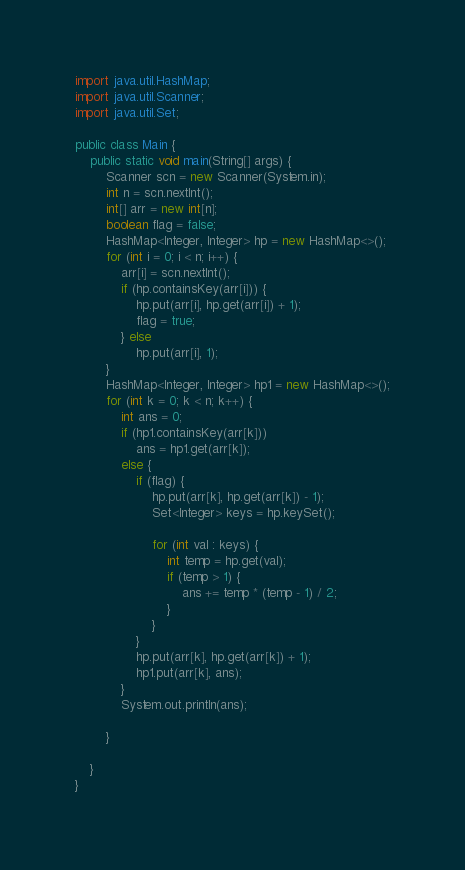<code> <loc_0><loc_0><loc_500><loc_500><_Java_>import java.util.HashMap;
import java.util.Scanner;
import java.util.Set;

public class Main {
	public static void main(String[] args) {
		Scanner scn = new Scanner(System.in);
		int n = scn.nextInt();
		int[] arr = new int[n];
		boolean flag = false;
		HashMap<Integer, Integer> hp = new HashMap<>();
		for (int i = 0; i < n; i++) {
			arr[i] = scn.nextInt();
			if (hp.containsKey(arr[i])) {
				hp.put(arr[i], hp.get(arr[i]) + 1);
				flag = true;
			} else
				hp.put(arr[i], 1);
		}
		HashMap<Integer, Integer> hp1 = new HashMap<>();
		for (int k = 0; k < n; k++) {
			int ans = 0;
			if (hp1.containsKey(arr[k]))
				ans = hp1.get(arr[k]);
			else {
				if (flag) {
					hp.put(arr[k], hp.get(arr[k]) - 1);
					Set<Integer> keys = hp.keySet();

					for (int val : keys) {
						int temp = hp.get(val);
						if (temp > 1) {
							ans += temp * (temp - 1) / 2;
						}
					}
				}
				hp.put(arr[k], hp.get(arr[k]) + 1);
				hp1.put(arr[k], ans);
			}
			System.out.println(ans);

		}

	}
}
</code> 